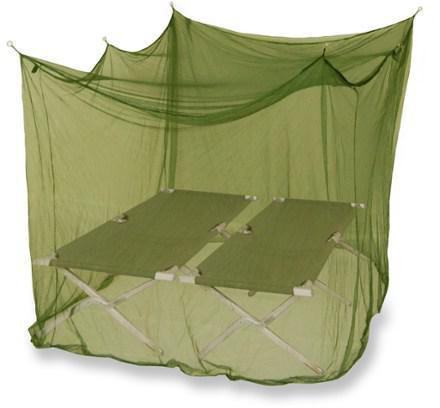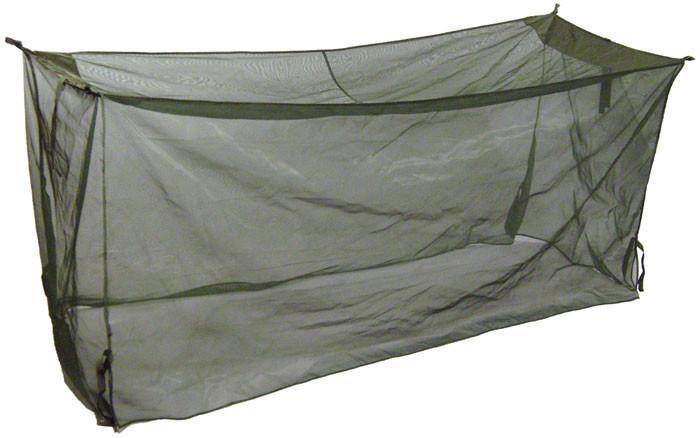The first image is the image on the left, the second image is the image on the right. Evaluate the accuracy of this statement regarding the images: "There is grass visible on one of the images.". Is it true? Answer yes or no. No. The first image is the image on the left, the second image is the image on the right. For the images shown, is this caption "there is a person in one of the images" true? Answer yes or no. No. 